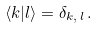Convert formula to latex. <formula><loc_0><loc_0><loc_500><loc_500>\left < k | l \right > = \delta _ { k , \, l } \, .</formula> 